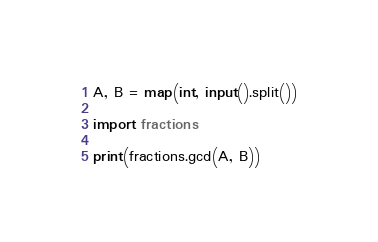<code> <loc_0><loc_0><loc_500><loc_500><_Python_>A, B = map(int, input().split())

import fractions

print(fractions.gcd(A, B))
</code> 